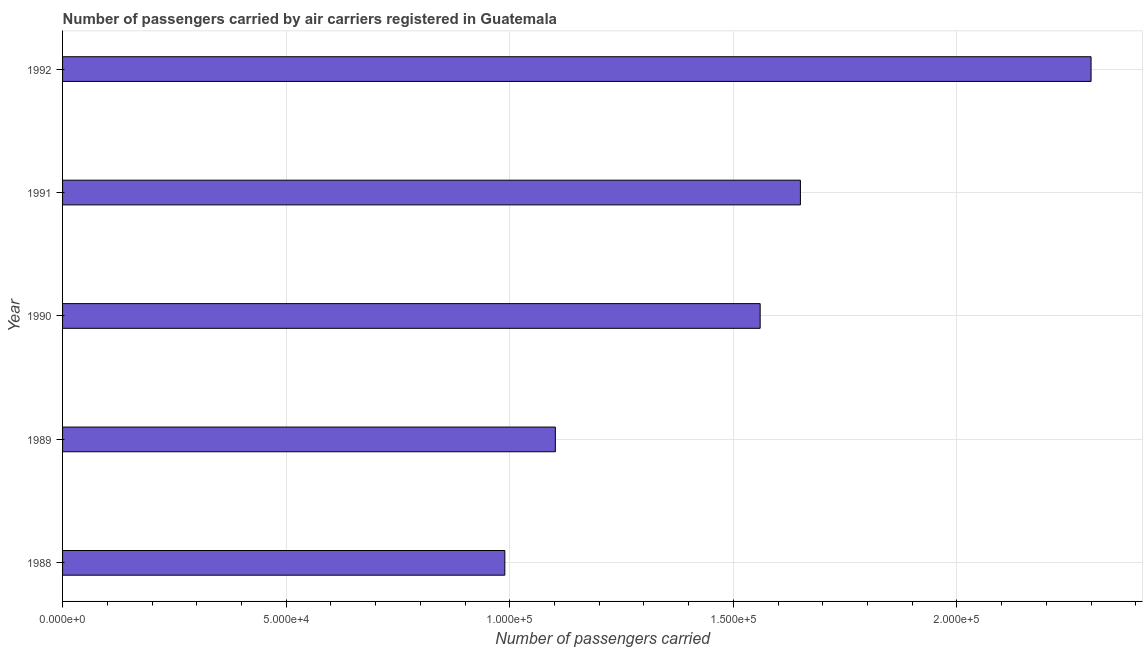Does the graph contain any zero values?
Provide a short and direct response. No. What is the title of the graph?
Offer a very short reply. Number of passengers carried by air carriers registered in Guatemala. What is the label or title of the X-axis?
Offer a terse response. Number of passengers carried. What is the label or title of the Y-axis?
Your answer should be compact. Year. What is the number of passengers carried in 1990?
Offer a terse response. 1.56e+05. Across all years, what is the maximum number of passengers carried?
Your response must be concise. 2.30e+05. Across all years, what is the minimum number of passengers carried?
Provide a succinct answer. 9.89e+04. In which year was the number of passengers carried maximum?
Your response must be concise. 1992. What is the sum of the number of passengers carried?
Your answer should be compact. 7.60e+05. What is the difference between the number of passengers carried in 1989 and 1992?
Give a very brief answer. -1.20e+05. What is the average number of passengers carried per year?
Offer a very short reply. 1.52e+05. What is the median number of passengers carried?
Provide a short and direct response. 1.56e+05. In how many years, is the number of passengers carried greater than 150000 ?
Your answer should be compact. 3. Do a majority of the years between 1991 and 1990 (inclusive) have number of passengers carried greater than 190000 ?
Provide a short and direct response. No. What is the ratio of the number of passengers carried in 1990 to that in 1992?
Your answer should be compact. 0.68. Is the number of passengers carried in 1988 less than that in 1991?
Offer a terse response. Yes. What is the difference between the highest and the second highest number of passengers carried?
Your answer should be very brief. 6.50e+04. What is the difference between the highest and the lowest number of passengers carried?
Provide a succinct answer. 1.31e+05. In how many years, is the number of passengers carried greater than the average number of passengers carried taken over all years?
Your answer should be compact. 3. Are all the bars in the graph horizontal?
Offer a very short reply. Yes. What is the difference between two consecutive major ticks on the X-axis?
Give a very brief answer. 5.00e+04. What is the Number of passengers carried in 1988?
Ensure brevity in your answer.  9.89e+04. What is the Number of passengers carried of 1989?
Your response must be concise. 1.10e+05. What is the Number of passengers carried in 1990?
Your answer should be very brief. 1.56e+05. What is the Number of passengers carried of 1991?
Your answer should be very brief. 1.65e+05. What is the difference between the Number of passengers carried in 1988 and 1989?
Offer a very short reply. -1.13e+04. What is the difference between the Number of passengers carried in 1988 and 1990?
Your answer should be compact. -5.71e+04. What is the difference between the Number of passengers carried in 1988 and 1991?
Your answer should be compact. -6.61e+04. What is the difference between the Number of passengers carried in 1988 and 1992?
Your response must be concise. -1.31e+05. What is the difference between the Number of passengers carried in 1989 and 1990?
Your response must be concise. -4.58e+04. What is the difference between the Number of passengers carried in 1989 and 1991?
Your answer should be compact. -5.48e+04. What is the difference between the Number of passengers carried in 1989 and 1992?
Your response must be concise. -1.20e+05. What is the difference between the Number of passengers carried in 1990 and 1991?
Make the answer very short. -9000. What is the difference between the Number of passengers carried in 1990 and 1992?
Offer a very short reply. -7.40e+04. What is the difference between the Number of passengers carried in 1991 and 1992?
Offer a terse response. -6.50e+04. What is the ratio of the Number of passengers carried in 1988 to that in 1989?
Your response must be concise. 0.9. What is the ratio of the Number of passengers carried in 1988 to that in 1990?
Provide a short and direct response. 0.63. What is the ratio of the Number of passengers carried in 1988 to that in 1991?
Make the answer very short. 0.6. What is the ratio of the Number of passengers carried in 1988 to that in 1992?
Offer a terse response. 0.43. What is the ratio of the Number of passengers carried in 1989 to that in 1990?
Give a very brief answer. 0.71. What is the ratio of the Number of passengers carried in 1989 to that in 1991?
Keep it short and to the point. 0.67. What is the ratio of the Number of passengers carried in 1989 to that in 1992?
Give a very brief answer. 0.48. What is the ratio of the Number of passengers carried in 1990 to that in 1991?
Ensure brevity in your answer.  0.94. What is the ratio of the Number of passengers carried in 1990 to that in 1992?
Make the answer very short. 0.68. What is the ratio of the Number of passengers carried in 1991 to that in 1992?
Your response must be concise. 0.72. 